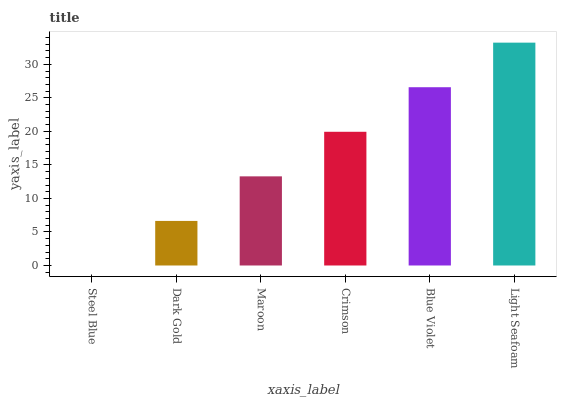Is Steel Blue the minimum?
Answer yes or no. Yes. Is Light Seafoam the maximum?
Answer yes or no. Yes. Is Dark Gold the minimum?
Answer yes or no. No. Is Dark Gold the maximum?
Answer yes or no. No. Is Dark Gold greater than Steel Blue?
Answer yes or no. Yes. Is Steel Blue less than Dark Gold?
Answer yes or no. Yes. Is Steel Blue greater than Dark Gold?
Answer yes or no. No. Is Dark Gold less than Steel Blue?
Answer yes or no. No. Is Crimson the high median?
Answer yes or no. Yes. Is Maroon the low median?
Answer yes or no. Yes. Is Steel Blue the high median?
Answer yes or no. No. Is Blue Violet the low median?
Answer yes or no. No. 